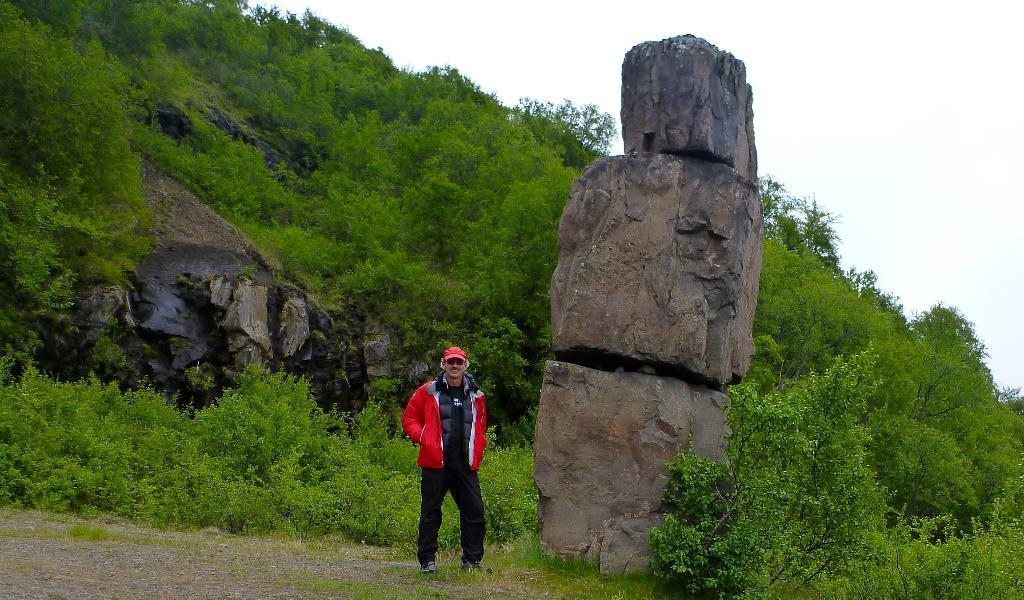Who or what is present in the image? There is a person in the image. What is the person doing or standing near? The person is standing beside a big stone. What can be seen in the distance in the image? There is a mountain in the background of the image. What features can be observed on the mountain? The mountain has stones and plants. What type of club does the person's grandfather own in the image? There is no mention of a club or the person's grandfather in the image. What hope does the person have for the future, as seen in the image? The image does not provide any information about the person's hopes or future plans. 